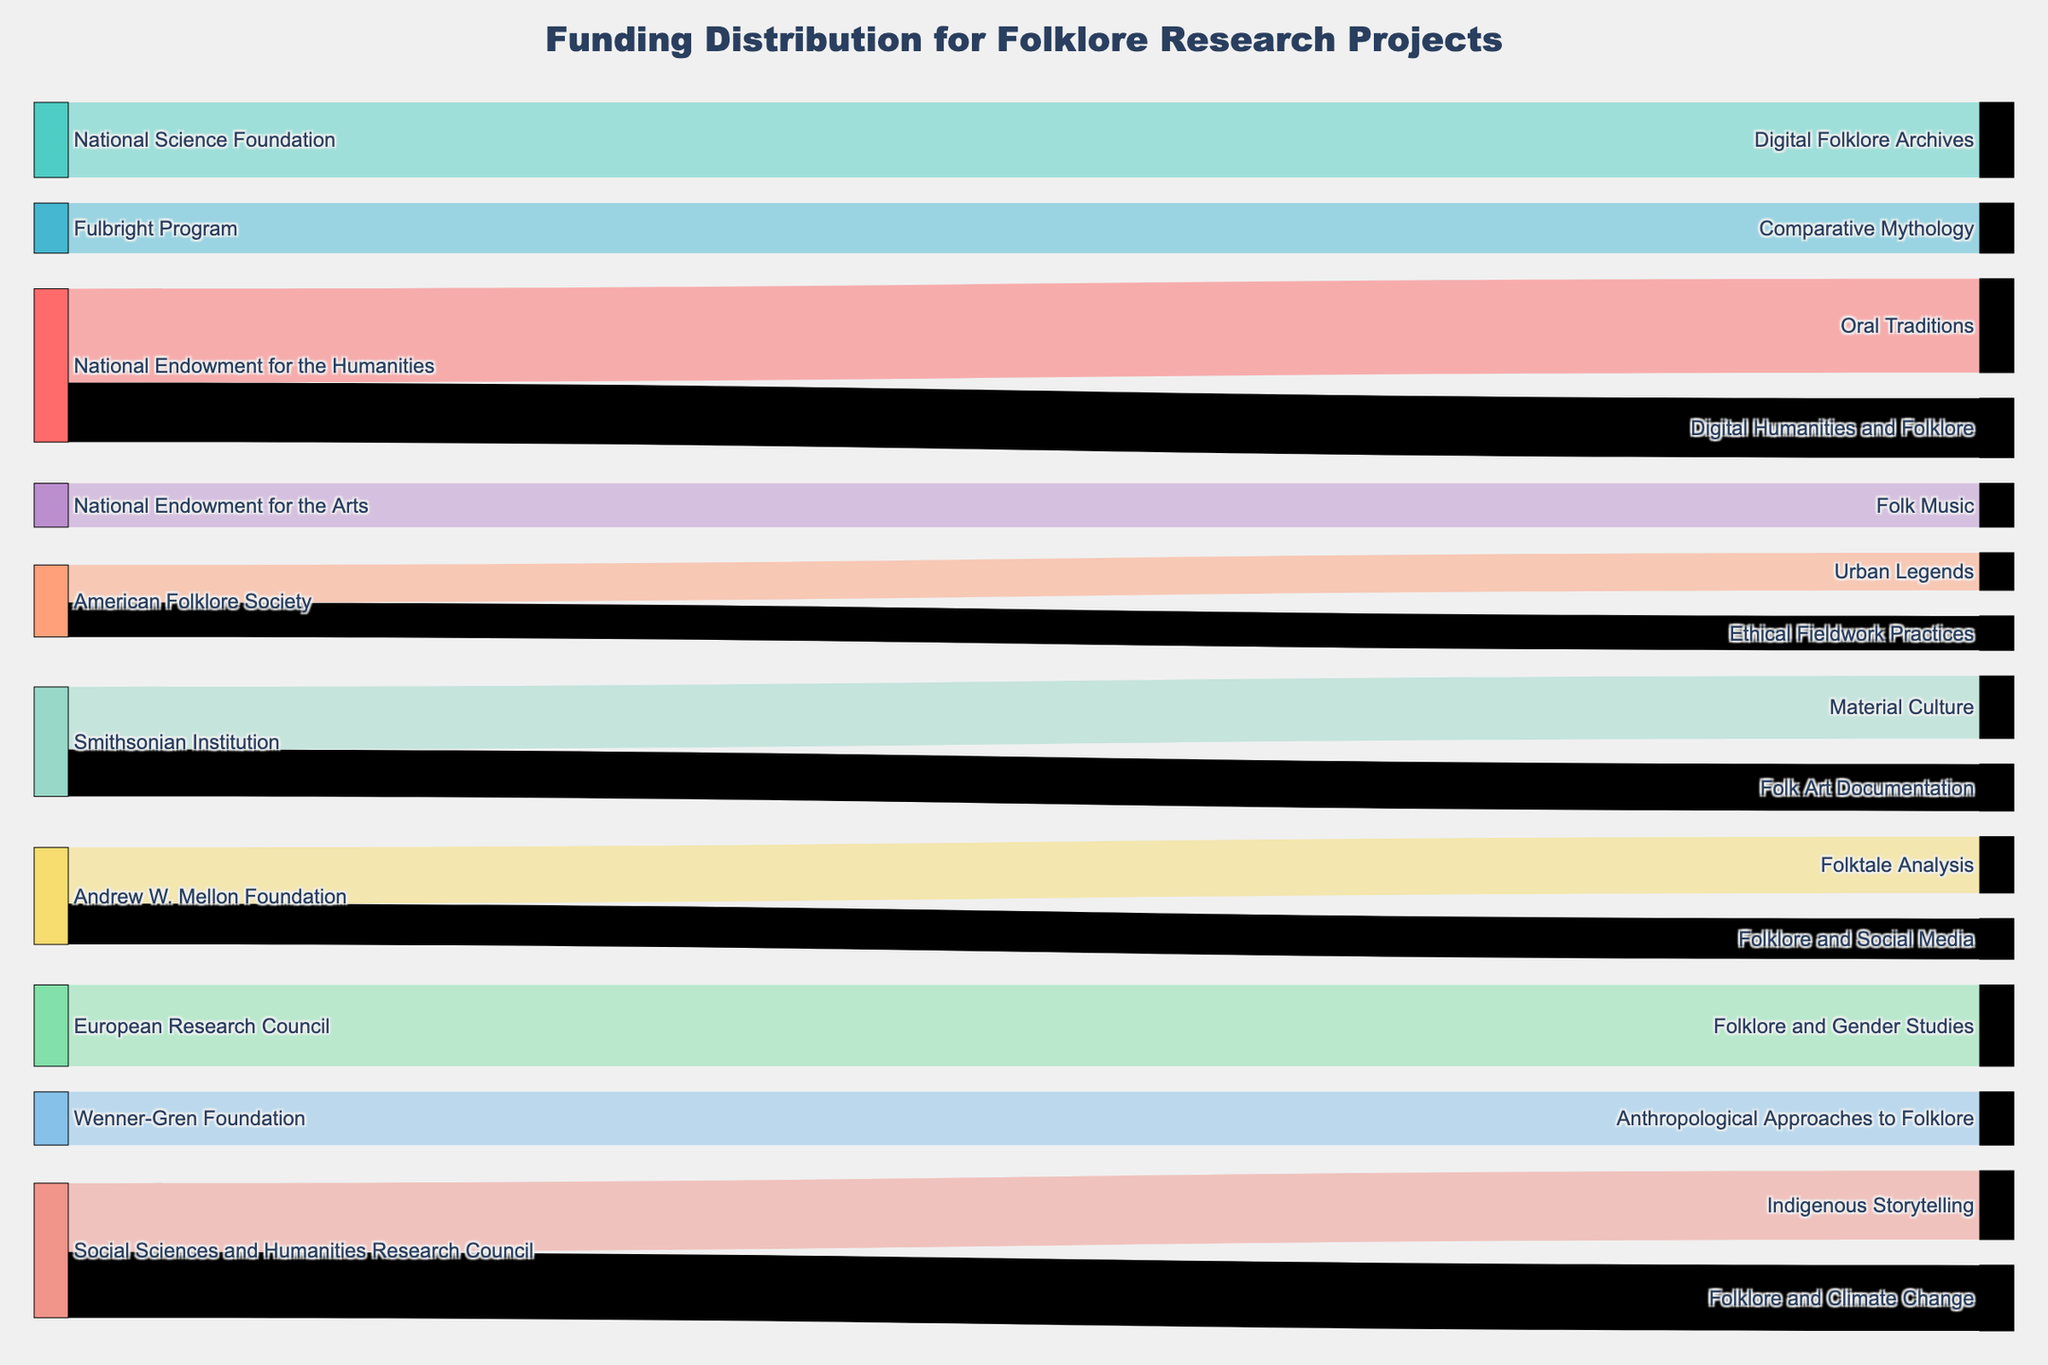What is the title of the Sankey Diagram? The title can be found at the top of the figure. It typically describes the subject of the diagram.
Answer: Funding Distribution for Folklore Research Projects Which source has funded the most for folklore research projects? Look at the widths of the lines connected to each source. The source with the widest total connection indicates the highest funding.
Answer: National Endowment for the Humanities How much funding did the National Science Foundation provide specifically for Digital Folklore Archives? Trace the line from the 'National Science Foundation' to 'Digital Folklore Archives'. The value beside the line is the specified funding.
Answer: $120,000 How does the funding for Oral Traditions compare to the funding for Urban Legends? Compare the widths of the lines connecting to 'Oral Traditions' and 'Urban Legends'. The wider the line, the greater the funding value.
Answer: Oral Traditions: $150,000; Urban Legends: $60,000 Which topic received the highest funding, and what is the amount? Identify the topic with the widest incoming lines from sources. The width represents the largest funding.
Answer: Oral Traditions; $150,000 What is the combined funding from the Smithsonian Institution? Sum the funds for topics 'Material Culture' and 'Folk Art Documentation' which are both funded by the Smithsonian Institution.
Answer: $100,000 + $75,000 = $175,000 What is the total amount of funding received for Digital Humanities and Folklore from the National Endowment for the Humanities? Trace the line from both 'National Endowment for the Humanities' to 'Digital Humanities and Folklore'. The amount labeled on the line gives the funding.
Answer: $95,000 How does the funding for American Folklore Society compare between Urban Legends and Ethical Fieldwork Practices? Compare the widths of the lines from 'American Folklore Society' to 'Urban Legends' and 'Ethical Fieldwork Practices'. The wider the line, the greater the funding value.
Answer: Urban Legends: $60,000; Ethical Fieldwork Practices: $55,000 Which funding source contributed to the least number of topics? Count the number of different topics funded by each source and identify the source with the fewest funded topics.
Answer: European Research Council (1 topic) How much total funding did Andrew W. Mellon Foundation provide? Add up the funding amounts of the topics funded by 'Andrew W. Mellon Foundation' which are Folktale Analysis and Folklore and Social Media.
Answer: $90,000 + $65,000 = $155,000 